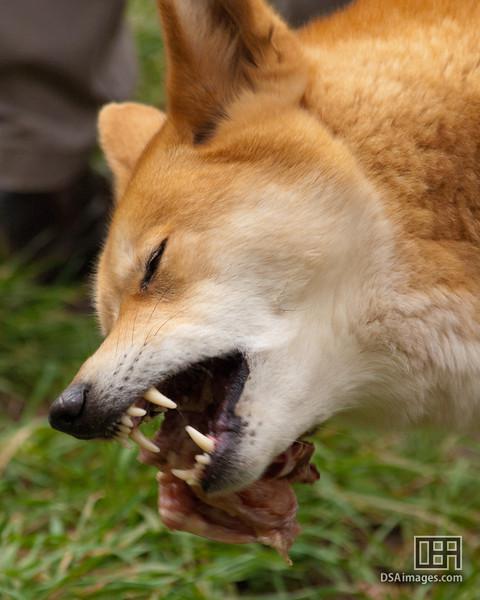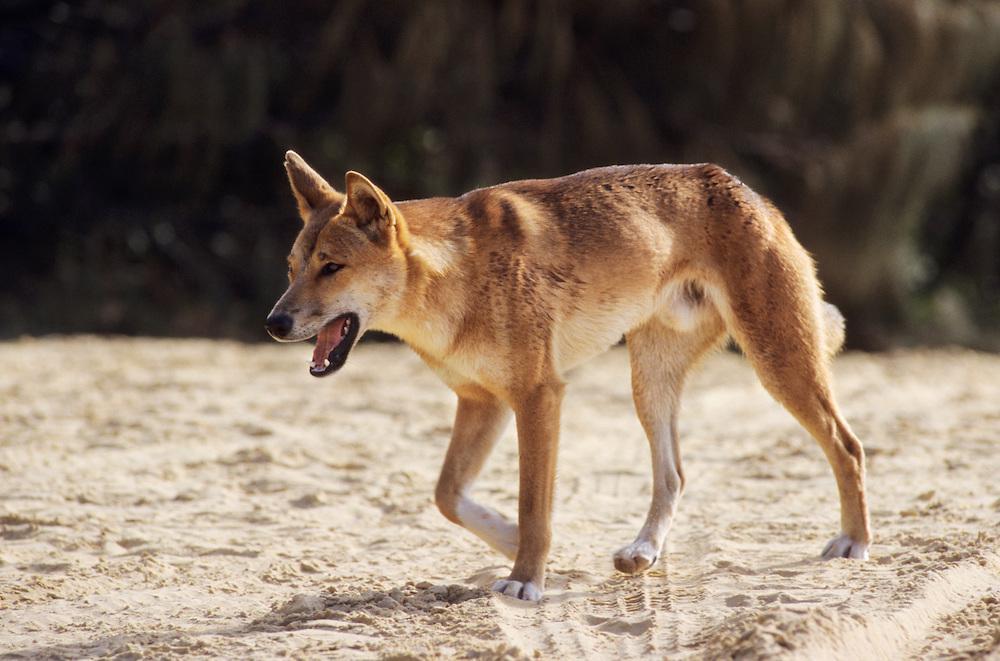The first image is the image on the left, the second image is the image on the right. Evaluate the accuracy of this statement regarding the images: "An image includes an adult dingo standing by at least three juvenile dogs.". Is it true? Answer yes or no. No. The first image is the image on the left, the second image is the image on the right. Considering the images on both sides, is "There are exactly two wild dogs." valid? Answer yes or no. Yes. 